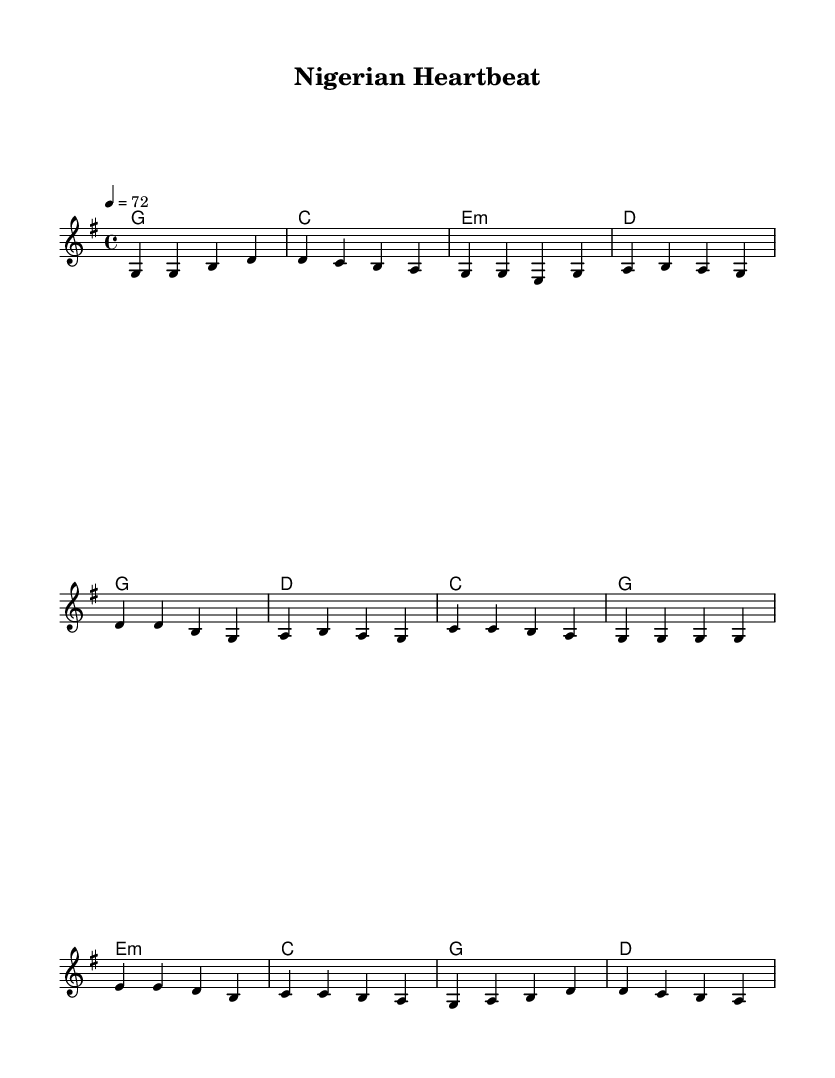What is the key signature of this music? The key signature is determined by the notes and chords used in the piece. In this case, the presence of an F sharp note is absent, and there are no flats indicated, which indicates the key is G major.
Answer: G major What is the time signature of the piece? The time signature is indicated in the beginning of the score. Here, it shows 4/4, which means there are four beats in each measure and the quarter note gets one beat.
Answer: 4/4 What is the tempo of the piece? The tempo is noted at the beginning of the score with the indication of 4 = 72, meaning there should be seventy-two beats per minute, and that the quarter note is counted as one beat.
Answer: 72 How many verses are in the sheet music? Counting the repetitions of the lyric sections in the score, there is one designated 'verse' section labeled as verse and separates into distinct lyrics and sections. Therefore, there is one verse.
Answer: One What is the primary theme of the lyrics? The lyrics focus on the diverse cultural heritage and unity of Nigeria. The lines in the verse and chorus reflect pride in Nigerian heritage and a sense of belonging to the land.
Answer: Nigerian heritage What type of music is represented in this sheet? By analyzing the genre indicated in the title and the stylistic elements present, the piece reflects characteristics typical of country rock, which blends elements of country music and rock music.
Answer: Country rock 